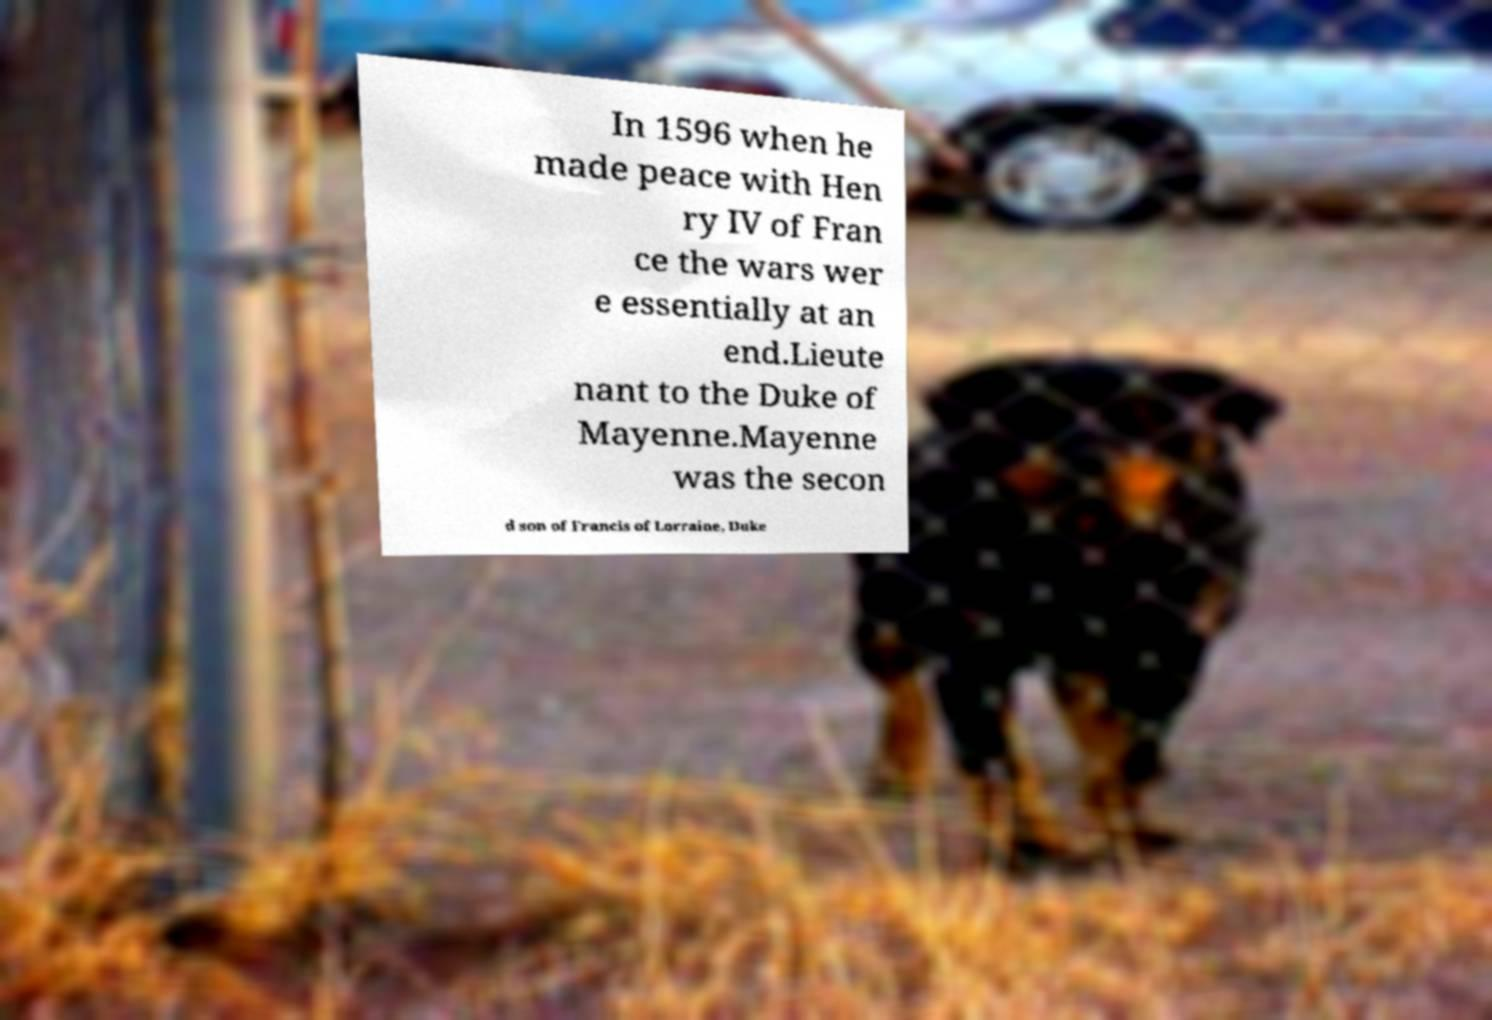Can you read and provide the text displayed in the image?This photo seems to have some interesting text. Can you extract and type it out for me? In 1596 when he made peace with Hen ry IV of Fran ce the wars wer e essentially at an end.Lieute nant to the Duke of Mayenne.Mayenne was the secon d son of Francis of Lorraine, Duke 